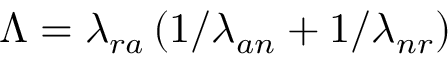<formula> <loc_0><loc_0><loc_500><loc_500>\Lambda = \lambda _ { r a } \left ( 1 / \lambda _ { a n } + 1 / \lambda _ { n r } \right )</formula> 